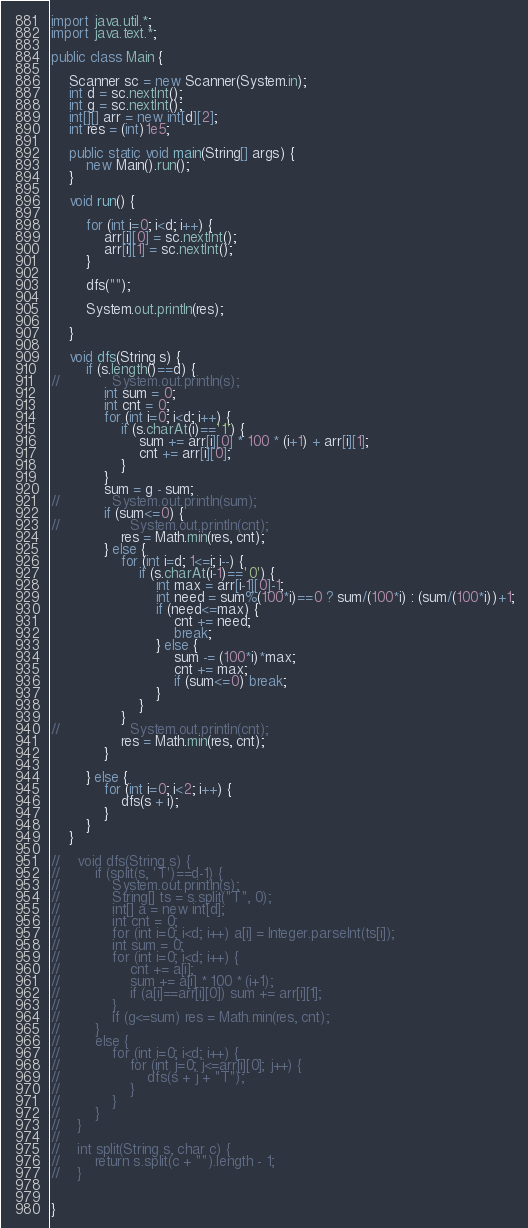<code> <loc_0><loc_0><loc_500><loc_500><_Java_>import java.util.*;
import java.text.*;

public class Main {

    Scanner sc = new Scanner(System.in);
    int d = sc.nextInt();
    int g = sc.nextInt();
    int[][] arr = new int[d][2];
    int res = (int)1e5;

    public static void main(String[] args) {
        new Main().run();
    }

    void run() {

        for (int i=0; i<d; i++) {
            arr[i][0] = sc.nextInt();
            arr[i][1] = sc.nextInt();
        }

        dfs("");

        System.out.println(res);

    }

    void dfs(String s) {
        if (s.length()==d) {
//            System.out.println(s);
            int sum = 0;
            int cnt = 0;
            for (int i=0; i<d; i++) {
                if (s.charAt(i)=='1') {
                    sum += arr[i][0] * 100 * (i+1) + arr[i][1];
                    cnt += arr[i][0];
                }
            }
            sum = g - sum;
//            System.out.println(sum);
            if (sum<=0) {
//                System.out.println(cnt);
                res = Math.min(res, cnt);
            } else {
                for (int i=d; 1<=i; i--) {
                    if (s.charAt(i-1)=='0') {
                        int max = arr[i-1][0]-1;
                        int need = sum%(100*i)==0 ? sum/(100*i) : (sum/(100*i))+1;
                        if (need<=max) {
                            cnt += need;
                            break;
                        } else {
                            sum -= (100*i)*max;
                            cnt += max;
                            if (sum<=0) break;
                        }
                    }
                }
//                System.out.println(cnt);
                res = Math.min(res, cnt);
            }

        } else {
            for (int i=0; i<2; i++) {
                dfs(s + i);
            }
        }
    }

//    void dfs(String s) {
//        if (split(s, 'T')==d-1) {
//            System.out.println(s);
//            String[] ts = s.split("T", 0);
//            int[] a = new int[d];
//            int cnt = 0;
//            for (int i=0; i<d; i++) a[i] = Integer.parseInt(ts[i]);
//            int sum = 0;
//            for (int i=0; i<d; i++) {
//                cnt += a[i];
//                sum += a[i] * 100 * (i+1);
//                if (a[i]==arr[i][0]) sum += arr[i][1];
//            }
//            if (g<=sum) res = Math.min(res, cnt);
//        }
//        else {
//            for (int i=0; i<d; i++) {
//                for (int j=0; j<=arr[i][0]; j++) {
//                    dfs(s + j + "T");
//                }
//            }
//        }
//    }
//
//    int split(String s, char c) {
//        return s.split(c + "").length - 1;
//    }


}
</code> 